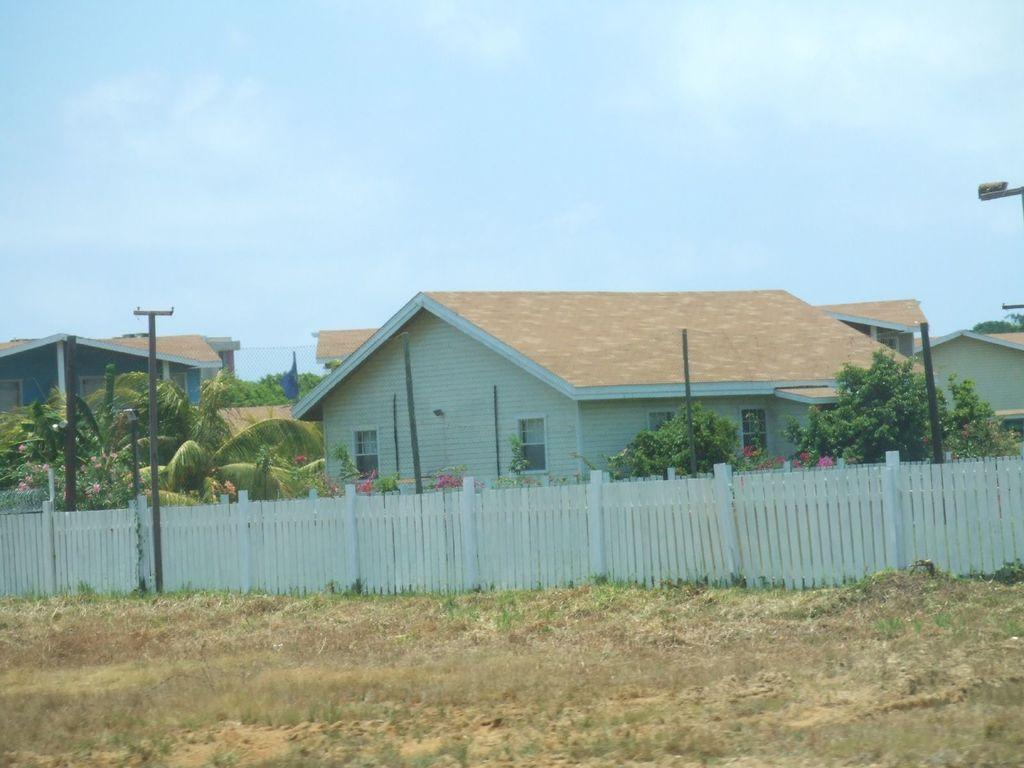What type of structures are located in the center of the image? There are houses in the center of the image. What type of vegetation can be seen in the image? There are trees in the image. What are the tall, thin objects in the image? There are poles in the image. What type of plants are present in the image? There are flowers in the image. What type of barrier is visible in the image? There is a fence in the image. What type of ground cover is at the bottom of the image? There is grass at the bottom of the image. What part of the natural environment is visible at the top of the image? There is sky visible at the top of the image. Where are the sticks used for underwear in the image? There are no sticks or underwear present in the image. What type of patch is sewn onto the fence in the image? There is no patch present on the fence in the image. 